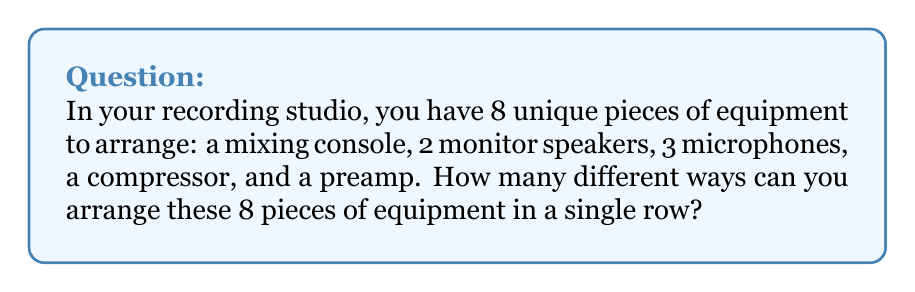Help me with this question. Let's approach this step-by-step:

1) We have 8 unique pieces of equipment. This means each piece is distinct from the others, even if they are the same type of equipment (like the 3 microphones).

2) When we're arranging distinct objects in a line, we're dealing with a permutation.

3) The number of permutations of n distinct objects is given by the factorial of n, denoted as n!

4) In this case, n = 8 (total number of equipment pieces)

5) Therefore, the number of ways to arrange the equipment is 8!

6) Let's calculate 8!:

   $$8! = 8 \times 7 \times 6 \times 5 \times 4 \times 3 \times 2 \times 1 = 40,320$$

Thus, there are 40,320 different ways to arrange the 8 pieces of equipment in a single row.

This large number illustrates why studio setup is so personal and varied - there are many, many ways to arrange even a modest amount of equipment!
Answer: 40,320 